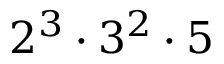<formula> <loc_0><loc_0><loc_500><loc_500>2 ^ { 3 } \cdot 3 ^ { 2 } \cdot 5</formula> 